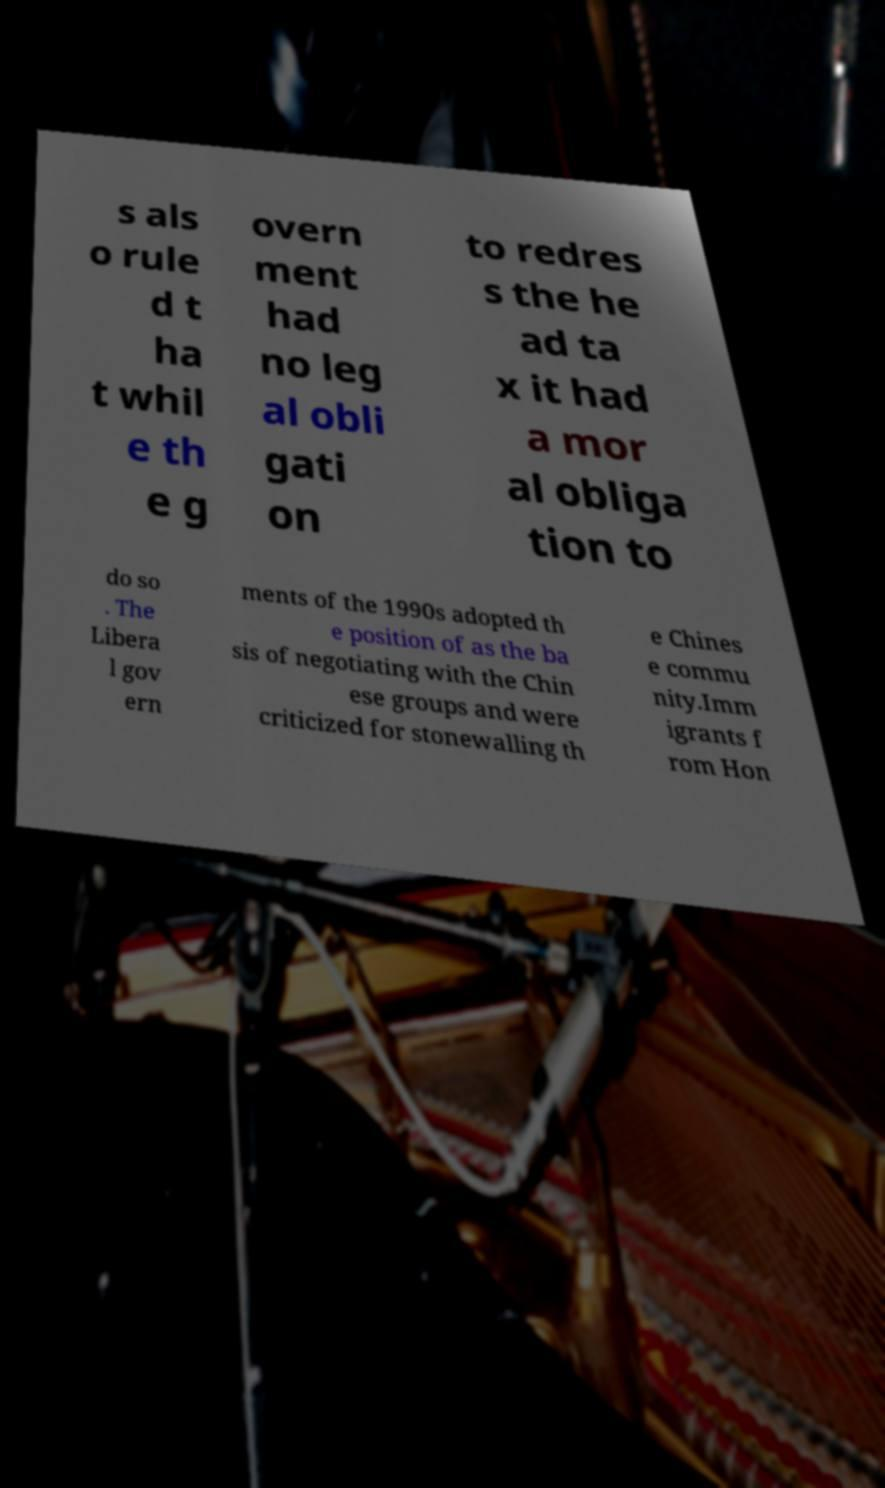There's text embedded in this image that I need extracted. Can you transcribe it verbatim? s als o rule d t ha t whil e th e g overn ment had no leg al obli gati on to redres s the he ad ta x it had a mor al obliga tion to do so . The Libera l gov ern ments of the 1990s adopted th e position of as the ba sis of negotiating with the Chin ese groups and were criticized for stonewalling th e Chines e commu nity.Imm igrants f rom Hon 